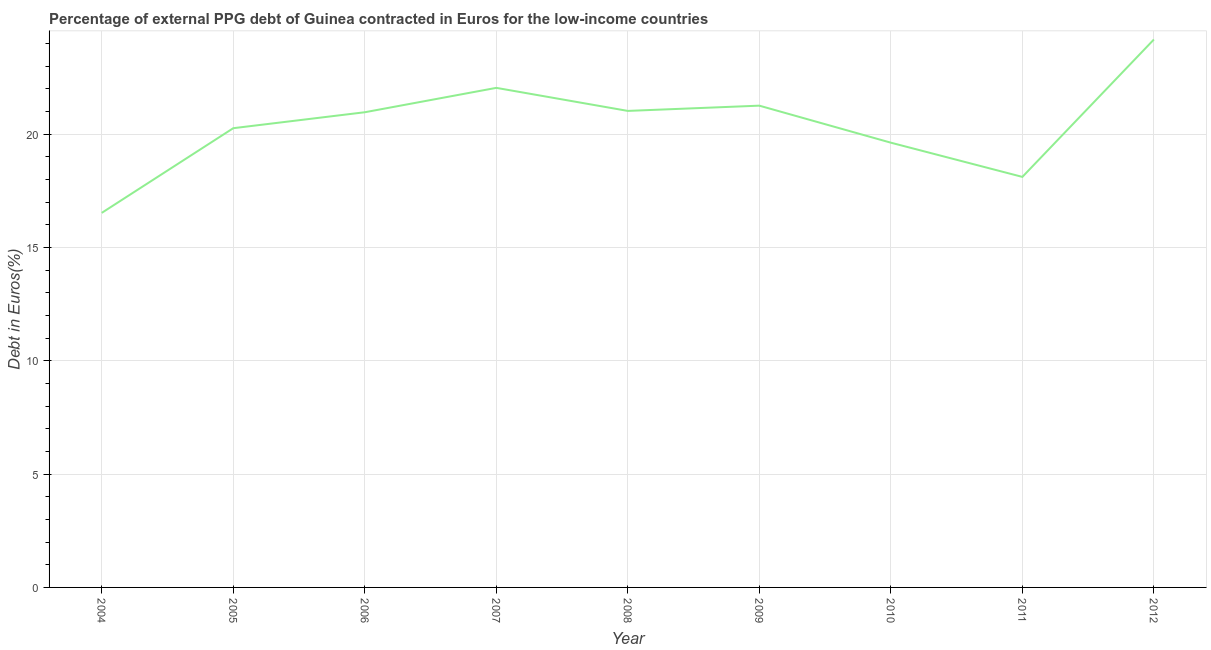What is the currency composition of ppg debt in 2010?
Offer a very short reply. 19.62. Across all years, what is the maximum currency composition of ppg debt?
Offer a very short reply. 24.17. Across all years, what is the minimum currency composition of ppg debt?
Your response must be concise. 16.52. In which year was the currency composition of ppg debt maximum?
Your answer should be very brief. 2012. In which year was the currency composition of ppg debt minimum?
Make the answer very short. 2004. What is the sum of the currency composition of ppg debt?
Give a very brief answer. 183.95. What is the difference between the currency composition of ppg debt in 2010 and 2011?
Provide a short and direct response. 1.51. What is the average currency composition of ppg debt per year?
Your answer should be very brief. 20.44. What is the median currency composition of ppg debt?
Provide a succinct answer. 20.96. Do a majority of the years between 2010 and 2006 (inclusive) have currency composition of ppg debt greater than 1 %?
Provide a short and direct response. Yes. What is the ratio of the currency composition of ppg debt in 2006 to that in 2008?
Keep it short and to the point. 1. Is the currency composition of ppg debt in 2007 less than that in 2008?
Your answer should be very brief. No. What is the difference between the highest and the second highest currency composition of ppg debt?
Make the answer very short. 2.13. Is the sum of the currency composition of ppg debt in 2004 and 2011 greater than the maximum currency composition of ppg debt across all years?
Provide a succinct answer. Yes. What is the difference between the highest and the lowest currency composition of ppg debt?
Make the answer very short. 7.65. Does the currency composition of ppg debt monotonically increase over the years?
Make the answer very short. No. Does the graph contain any zero values?
Make the answer very short. No. What is the title of the graph?
Give a very brief answer. Percentage of external PPG debt of Guinea contracted in Euros for the low-income countries. What is the label or title of the X-axis?
Your answer should be compact. Year. What is the label or title of the Y-axis?
Your answer should be compact. Debt in Euros(%). What is the Debt in Euros(%) of 2004?
Give a very brief answer. 16.52. What is the Debt in Euros(%) of 2005?
Offer a terse response. 20.26. What is the Debt in Euros(%) of 2006?
Your answer should be very brief. 20.96. What is the Debt in Euros(%) of 2007?
Ensure brevity in your answer.  22.04. What is the Debt in Euros(%) in 2008?
Ensure brevity in your answer.  21.02. What is the Debt in Euros(%) in 2009?
Give a very brief answer. 21.25. What is the Debt in Euros(%) of 2010?
Your response must be concise. 19.62. What is the Debt in Euros(%) of 2011?
Offer a terse response. 18.11. What is the Debt in Euros(%) of 2012?
Your response must be concise. 24.17. What is the difference between the Debt in Euros(%) in 2004 and 2005?
Ensure brevity in your answer.  -3.74. What is the difference between the Debt in Euros(%) in 2004 and 2006?
Provide a succinct answer. -4.44. What is the difference between the Debt in Euros(%) in 2004 and 2007?
Ensure brevity in your answer.  -5.51. What is the difference between the Debt in Euros(%) in 2004 and 2008?
Your response must be concise. -4.5. What is the difference between the Debt in Euros(%) in 2004 and 2009?
Provide a succinct answer. -4.73. What is the difference between the Debt in Euros(%) in 2004 and 2010?
Your response must be concise. -3.1. What is the difference between the Debt in Euros(%) in 2004 and 2011?
Your answer should be compact. -1.59. What is the difference between the Debt in Euros(%) in 2004 and 2012?
Your response must be concise. -7.65. What is the difference between the Debt in Euros(%) in 2005 and 2006?
Make the answer very short. -0.7. What is the difference between the Debt in Euros(%) in 2005 and 2007?
Keep it short and to the point. -1.78. What is the difference between the Debt in Euros(%) in 2005 and 2008?
Offer a terse response. -0.76. What is the difference between the Debt in Euros(%) in 2005 and 2009?
Keep it short and to the point. -0.99. What is the difference between the Debt in Euros(%) in 2005 and 2010?
Offer a very short reply. 0.64. What is the difference between the Debt in Euros(%) in 2005 and 2011?
Give a very brief answer. 2.15. What is the difference between the Debt in Euros(%) in 2005 and 2012?
Provide a succinct answer. -3.91. What is the difference between the Debt in Euros(%) in 2006 and 2007?
Give a very brief answer. -1.08. What is the difference between the Debt in Euros(%) in 2006 and 2008?
Your answer should be very brief. -0.06. What is the difference between the Debt in Euros(%) in 2006 and 2009?
Provide a succinct answer. -0.29. What is the difference between the Debt in Euros(%) in 2006 and 2010?
Offer a very short reply. 1.34. What is the difference between the Debt in Euros(%) in 2006 and 2011?
Your answer should be very brief. 2.85. What is the difference between the Debt in Euros(%) in 2006 and 2012?
Make the answer very short. -3.21. What is the difference between the Debt in Euros(%) in 2007 and 2008?
Give a very brief answer. 1.02. What is the difference between the Debt in Euros(%) in 2007 and 2009?
Make the answer very short. 0.79. What is the difference between the Debt in Euros(%) in 2007 and 2010?
Offer a terse response. 2.42. What is the difference between the Debt in Euros(%) in 2007 and 2011?
Ensure brevity in your answer.  3.93. What is the difference between the Debt in Euros(%) in 2007 and 2012?
Offer a terse response. -2.13. What is the difference between the Debt in Euros(%) in 2008 and 2009?
Your answer should be compact. -0.23. What is the difference between the Debt in Euros(%) in 2008 and 2010?
Your answer should be compact. 1.4. What is the difference between the Debt in Euros(%) in 2008 and 2011?
Keep it short and to the point. 2.91. What is the difference between the Debt in Euros(%) in 2008 and 2012?
Make the answer very short. -3.15. What is the difference between the Debt in Euros(%) in 2009 and 2010?
Your answer should be compact. 1.63. What is the difference between the Debt in Euros(%) in 2009 and 2011?
Your answer should be compact. 3.14. What is the difference between the Debt in Euros(%) in 2009 and 2012?
Provide a short and direct response. -2.92. What is the difference between the Debt in Euros(%) in 2010 and 2011?
Make the answer very short. 1.51. What is the difference between the Debt in Euros(%) in 2010 and 2012?
Your response must be concise. -4.55. What is the difference between the Debt in Euros(%) in 2011 and 2012?
Give a very brief answer. -6.06. What is the ratio of the Debt in Euros(%) in 2004 to that in 2005?
Offer a terse response. 0.82. What is the ratio of the Debt in Euros(%) in 2004 to that in 2006?
Your response must be concise. 0.79. What is the ratio of the Debt in Euros(%) in 2004 to that in 2008?
Offer a terse response. 0.79. What is the ratio of the Debt in Euros(%) in 2004 to that in 2009?
Offer a terse response. 0.78. What is the ratio of the Debt in Euros(%) in 2004 to that in 2010?
Your response must be concise. 0.84. What is the ratio of the Debt in Euros(%) in 2004 to that in 2011?
Your answer should be very brief. 0.91. What is the ratio of the Debt in Euros(%) in 2004 to that in 2012?
Offer a very short reply. 0.68. What is the ratio of the Debt in Euros(%) in 2005 to that in 2007?
Give a very brief answer. 0.92. What is the ratio of the Debt in Euros(%) in 2005 to that in 2009?
Keep it short and to the point. 0.95. What is the ratio of the Debt in Euros(%) in 2005 to that in 2010?
Give a very brief answer. 1.03. What is the ratio of the Debt in Euros(%) in 2005 to that in 2011?
Your answer should be very brief. 1.12. What is the ratio of the Debt in Euros(%) in 2005 to that in 2012?
Keep it short and to the point. 0.84. What is the ratio of the Debt in Euros(%) in 2006 to that in 2007?
Ensure brevity in your answer.  0.95. What is the ratio of the Debt in Euros(%) in 2006 to that in 2008?
Your response must be concise. 1. What is the ratio of the Debt in Euros(%) in 2006 to that in 2010?
Give a very brief answer. 1.07. What is the ratio of the Debt in Euros(%) in 2006 to that in 2011?
Provide a succinct answer. 1.16. What is the ratio of the Debt in Euros(%) in 2006 to that in 2012?
Offer a terse response. 0.87. What is the ratio of the Debt in Euros(%) in 2007 to that in 2008?
Your response must be concise. 1.05. What is the ratio of the Debt in Euros(%) in 2007 to that in 2009?
Provide a succinct answer. 1.04. What is the ratio of the Debt in Euros(%) in 2007 to that in 2010?
Your response must be concise. 1.12. What is the ratio of the Debt in Euros(%) in 2007 to that in 2011?
Provide a succinct answer. 1.22. What is the ratio of the Debt in Euros(%) in 2007 to that in 2012?
Offer a very short reply. 0.91. What is the ratio of the Debt in Euros(%) in 2008 to that in 2009?
Make the answer very short. 0.99. What is the ratio of the Debt in Euros(%) in 2008 to that in 2010?
Your answer should be compact. 1.07. What is the ratio of the Debt in Euros(%) in 2008 to that in 2011?
Make the answer very short. 1.16. What is the ratio of the Debt in Euros(%) in 2008 to that in 2012?
Make the answer very short. 0.87. What is the ratio of the Debt in Euros(%) in 2009 to that in 2010?
Provide a short and direct response. 1.08. What is the ratio of the Debt in Euros(%) in 2009 to that in 2011?
Offer a terse response. 1.17. What is the ratio of the Debt in Euros(%) in 2009 to that in 2012?
Your answer should be very brief. 0.88. What is the ratio of the Debt in Euros(%) in 2010 to that in 2011?
Offer a terse response. 1.08. What is the ratio of the Debt in Euros(%) in 2010 to that in 2012?
Keep it short and to the point. 0.81. What is the ratio of the Debt in Euros(%) in 2011 to that in 2012?
Ensure brevity in your answer.  0.75. 